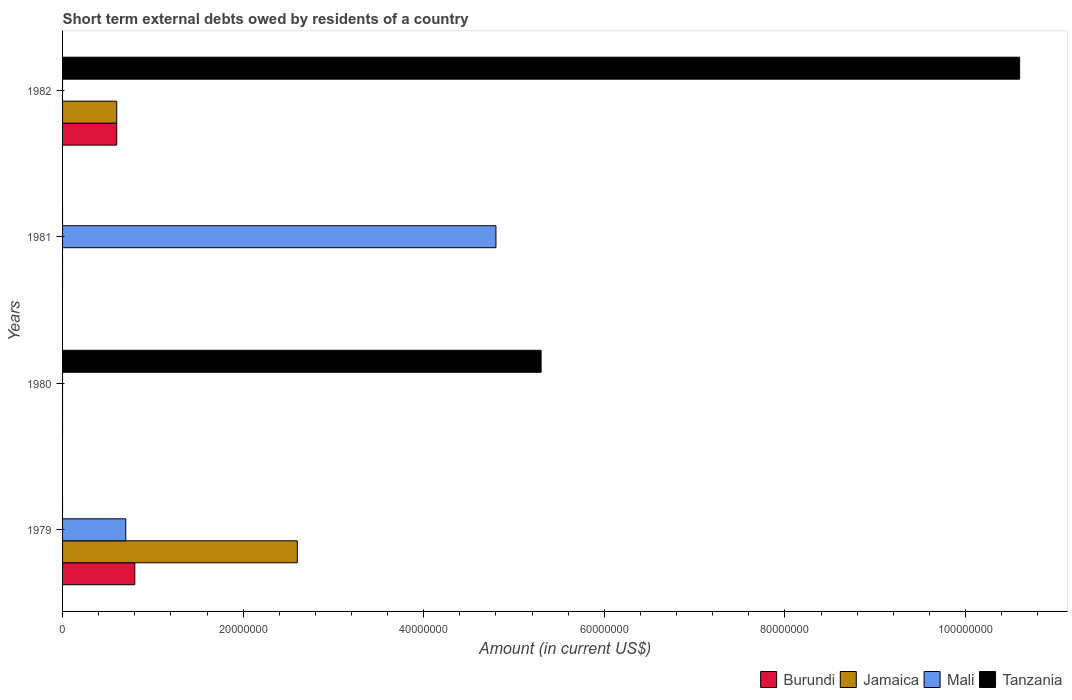How many different coloured bars are there?
Ensure brevity in your answer.  4. What is the label of the 2nd group of bars from the top?
Keep it short and to the point. 1981. In how many cases, is the number of bars for a given year not equal to the number of legend labels?
Make the answer very short. 4. What is the amount of short-term external debts owed by residents in Burundi in 1979?
Keep it short and to the point. 8.00e+06. Across all years, what is the maximum amount of short-term external debts owed by residents in Jamaica?
Offer a very short reply. 2.60e+07. Across all years, what is the minimum amount of short-term external debts owed by residents in Tanzania?
Offer a very short reply. 0. In which year was the amount of short-term external debts owed by residents in Tanzania maximum?
Keep it short and to the point. 1982. What is the total amount of short-term external debts owed by residents in Burundi in the graph?
Your response must be concise. 1.40e+07. What is the difference between the amount of short-term external debts owed by residents in Mali in 1981 and the amount of short-term external debts owed by residents in Jamaica in 1980?
Keep it short and to the point. 4.80e+07. What is the average amount of short-term external debts owed by residents in Tanzania per year?
Provide a succinct answer. 3.98e+07. In the year 1982, what is the difference between the amount of short-term external debts owed by residents in Burundi and amount of short-term external debts owed by residents in Jamaica?
Your answer should be compact. 0. In how many years, is the amount of short-term external debts owed by residents in Mali greater than 104000000 US$?
Your answer should be very brief. 0. Is the amount of short-term external debts owed by residents in Jamaica in 1979 less than that in 1982?
Your answer should be compact. No. What is the difference between the highest and the lowest amount of short-term external debts owed by residents in Jamaica?
Your answer should be very brief. 2.60e+07. In how many years, is the amount of short-term external debts owed by residents in Mali greater than the average amount of short-term external debts owed by residents in Mali taken over all years?
Provide a succinct answer. 1. Is it the case that in every year, the sum of the amount of short-term external debts owed by residents in Jamaica and amount of short-term external debts owed by residents in Burundi is greater than the amount of short-term external debts owed by residents in Tanzania?
Give a very brief answer. No. How many bars are there?
Make the answer very short. 8. Are all the bars in the graph horizontal?
Offer a very short reply. Yes. How many years are there in the graph?
Offer a terse response. 4. Does the graph contain grids?
Your answer should be compact. No. How many legend labels are there?
Ensure brevity in your answer.  4. What is the title of the graph?
Offer a very short reply. Short term external debts owed by residents of a country. What is the Amount (in current US$) in Burundi in 1979?
Offer a terse response. 8.00e+06. What is the Amount (in current US$) of Jamaica in 1979?
Your answer should be very brief. 2.60e+07. What is the Amount (in current US$) of Tanzania in 1979?
Offer a terse response. 0. What is the Amount (in current US$) of Jamaica in 1980?
Keep it short and to the point. 0. What is the Amount (in current US$) of Mali in 1980?
Ensure brevity in your answer.  0. What is the Amount (in current US$) of Tanzania in 1980?
Your answer should be compact. 5.30e+07. What is the Amount (in current US$) in Burundi in 1981?
Provide a succinct answer. 0. What is the Amount (in current US$) in Mali in 1981?
Give a very brief answer. 4.80e+07. What is the Amount (in current US$) of Tanzania in 1981?
Your answer should be compact. 0. What is the Amount (in current US$) in Burundi in 1982?
Your answer should be very brief. 6.00e+06. What is the Amount (in current US$) of Tanzania in 1982?
Your response must be concise. 1.06e+08. Across all years, what is the maximum Amount (in current US$) of Burundi?
Give a very brief answer. 8.00e+06. Across all years, what is the maximum Amount (in current US$) of Jamaica?
Make the answer very short. 2.60e+07. Across all years, what is the maximum Amount (in current US$) of Mali?
Make the answer very short. 4.80e+07. Across all years, what is the maximum Amount (in current US$) of Tanzania?
Provide a short and direct response. 1.06e+08. Across all years, what is the minimum Amount (in current US$) in Burundi?
Provide a succinct answer. 0. Across all years, what is the minimum Amount (in current US$) of Jamaica?
Give a very brief answer. 0. Across all years, what is the minimum Amount (in current US$) of Mali?
Your answer should be compact. 0. Across all years, what is the minimum Amount (in current US$) of Tanzania?
Offer a terse response. 0. What is the total Amount (in current US$) of Burundi in the graph?
Make the answer very short. 1.40e+07. What is the total Amount (in current US$) of Jamaica in the graph?
Make the answer very short. 3.20e+07. What is the total Amount (in current US$) in Mali in the graph?
Give a very brief answer. 5.50e+07. What is the total Amount (in current US$) of Tanzania in the graph?
Offer a very short reply. 1.59e+08. What is the difference between the Amount (in current US$) in Mali in 1979 and that in 1981?
Provide a short and direct response. -4.10e+07. What is the difference between the Amount (in current US$) in Burundi in 1979 and that in 1982?
Your response must be concise. 2.00e+06. What is the difference between the Amount (in current US$) of Tanzania in 1980 and that in 1982?
Your response must be concise. -5.30e+07. What is the difference between the Amount (in current US$) of Burundi in 1979 and the Amount (in current US$) of Tanzania in 1980?
Provide a short and direct response. -4.50e+07. What is the difference between the Amount (in current US$) in Jamaica in 1979 and the Amount (in current US$) in Tanzania in 1980?
Ensure brevity in your answer.  -2.70e+07. What is the difference between the Amount (in current US$) of Mali in 1979 and the Amount (in current US$) of Tanzania in 1980?
Your response must be concise. -4.60e+07. What is the difference between the Amount (in current US$) in Burundi in 1979 and the Amount (in current US$) in Mali in 1981?
Your answer should be very brief. -4.00e+07. What is the difference between the Amount (in current US$) of Jamaica in 1979 and the Amount (in current US$) of Mali in 1981?
Your answer should be compact. -2.20e+07. What is the difference between the Amount (in current US$) in Burundi in 1979 and the Amount (in current US$) in Jamaica in 1982?
Your answer should be very brief. 2.00e+06. What is the difference between the Amount (in current US$) of Burundi in 1979 and the Amount (in current US$) of Tanzania in 1982?
Provide a short and direct response. -9.80e+07. What is the difference between the Amount (in current US$) in Jamaica in 1979 and the Amount (in current US$) in Tanzania in 1982?
Ensure brevity in your answer.  -8.00e+07. What is the difference between the Amount (in current US$) of Mali in 1979 and the Amount (in current US$) of Tanzania in 1982?
Provide a short and direct response. -9.90e+07. What is the difference between the Amount (in current US$) of Mali in 1981 and the Amount (in current US$) of Tanzania in 1982?
Your answer should be compact. -5.80e+07. What is the average Amount (in current US$) of Burundi per year?
Offer a terse response. 3.50e+06. What is the average Amount (in current US$) of Mali per year?
Your answer should be compact. 1.38e+07. What is the average Amount (in current US$) of Tanzania per year?
Keep it short and to the point. 3.98e+07. In the year 1979, what is the difference between the Amount (in current US$) of Burundi and Amount (in current US$) of Jamaica?
Your answer should be compact. -1.80e+07. In the year 1979, what is the difference between the Amount (in current US$) of Jamaica and Amount (in current US$) of Mali?
Offer a terse response. 1.90e+07. In the year 1982, what is the difference between the Amount (in current US$) in Burundi and Amount (in current US$) in Tanzania?
Make the answer very short. -1.00e+08. In the year 1982, what is the difference between the Amount (in current US$) of Jamaica and Amount (in current US$) of Tanzania?
Your answer should be very brief. -1.00e+08. What is the ratio of the Amount (in current US$) in Mali in 1979 to that in 1981?
Give a very brief answer. 0.15. What is the ratio of the Amount (in current US$) of Jamaica in 1979 to that in 1982?
Ensure brevity in your answer.  4.33. What is the difference between the highest and the lowest Amount (in current US$) in Jamaica?
Offer a terse response. 2.60e+07. What is the difference between the highest and the lowest Amount (in current US$) in Mali?
Ensure brevity in your answer.  4.80e+07. What is the difference between the highest and the lowest Amount (in current US$) of Tanzania?
Provide a succinct answer. 1.06e+08. 